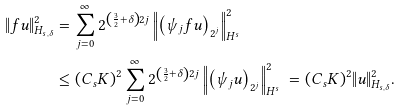<formula> <loc_0><loc_0><loc_500><loc_500>\| f u \| _ { H _ { s , \delta } } ^ { 2 } & = \sum _ { j = 0 } ^ { \infty } 2 ^ { \left ( \frac { 3 } { 2 } + \delta \right ) 2 j } \left \| \left ( \psi _ { j } f u \right ) _ { 2 ^ { j } } \right \| _ { H ^ { s } } ^ { 2 } \\ & \leq ( C _ { s } K ) ^ { 2 } \sum _ { j = 0 } ^ { \infty } 2 ^ { \left ( \frac { 3 } { 2 } + \delta \right ) 2 j } \left \| \left ( \psi _ { j } u \right ) _ { 2 ^ { j } } \right \| _ { H ^ { s } } ^ { 2 } \ = ( C _ { s } K ) ^ { 2 } \| u \| _ { H _ { s , \delta } } ^ { 2 } .</formula> 